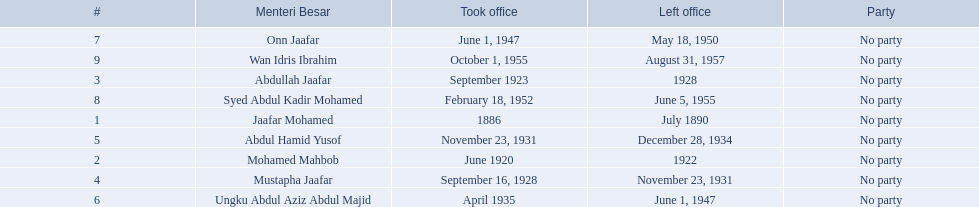When did jaafar mohamed take office? 1886. When did mohamed mahbob take office? June 1920. Who was in office no more than 4 years? Mohamed Mahbob. 